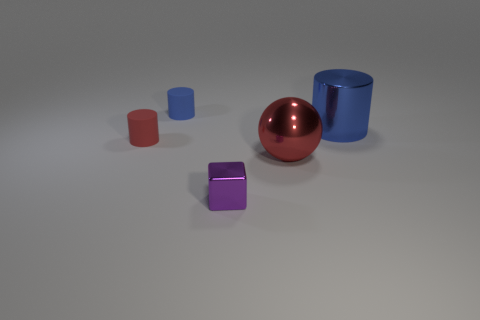Can you tell me how many objects are in the image? There are five objects in the image: two cylinders, two cubes, and one sphere. 